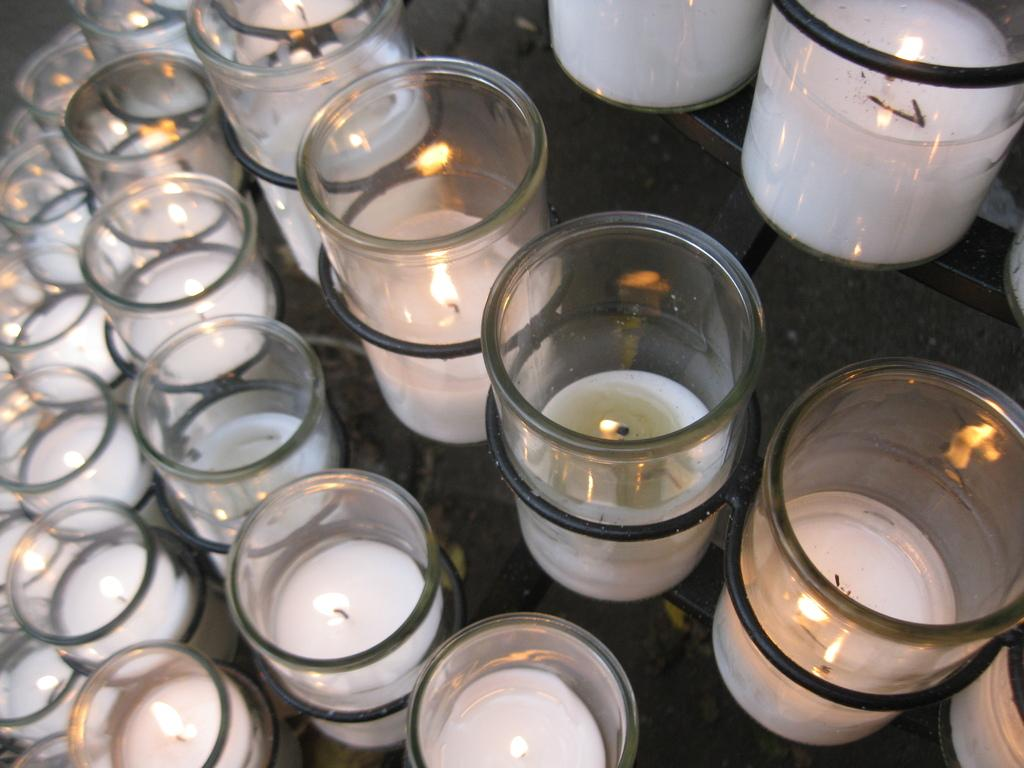What type of objects are present in large numbers in the image? There are many white color tea candles in the image. What is the surface on which the tea candles are placed? The tea candles are placed on a glass table top. Can you tell me about the history of the elbow in the image? There is no mention of an elbow or any historical context in the image; it features many white color tea candles placed on a glass table top. Is there a rabbit visible in the image? There is no rabbit present in the image. 